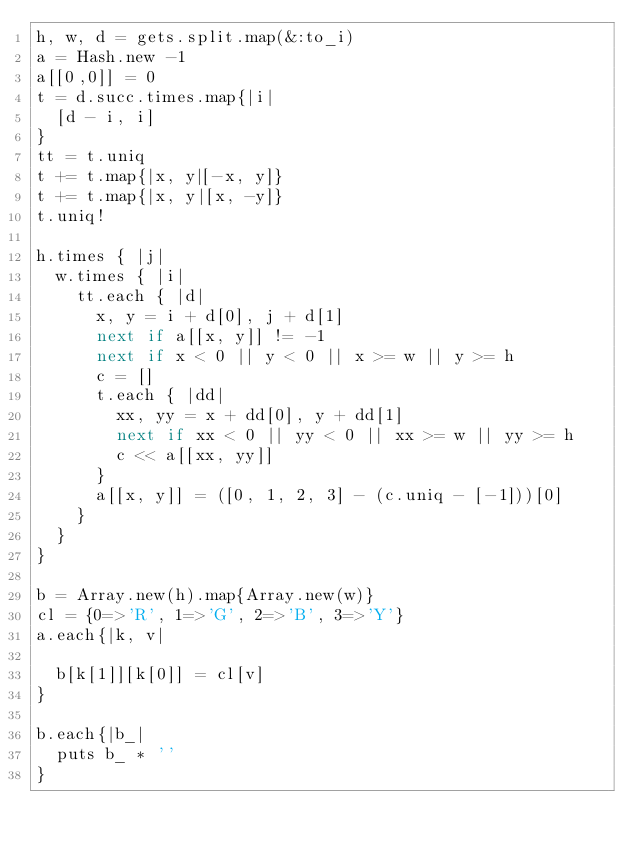Convert code to text. <code><loc_0><loc_0><loc_500><loc_500><_Ruby_>h, w, d = gets.split.map(&:to_i)
a = Hash.new -1
a[[0,0]] = 0
t = d.succ.times.map{|i|
  [d - i, i]
}
tt = t.uniq
t += t.map{|x, y|[-x, y]}
t += t.map{|x, y|[x, -y]}
t.uniq!

h.times { |j|
  w.times { |i|
    tt.each { |d|
      x, y = i + d[0], j + d[1]
      next if a[[x, y]] != -1
      next if x < 0 || y < 0 || x >= w || y >= h
      c = []
      t.each { |dd|
        xx, yy = x + dd[0], y + dd[1]
        next if xx < 0 || yy < 0 || xx >= w || yy >= h
        c << a[[xx, yy]]
      }
      a[[x, y]] = ([0, 1, 2, 3] - (c.uniq - [-1]))[0]
    }
  }
}

b = Array.new(h).map{Array.new(w)}
cl = {0=>'R', 1=>'G', 2=>'B', 3=>'Y'}
a.each{|k, v|

  b[k[1]][k[0]] = cl[v]
}

b.each{|b_|
  puts b_ * ''
}
</code> 